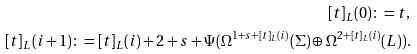Convert formula to latex. <formula><loc_0><loc_0><loc_500><loc_500>[ t ] _ { L } ( 0 ) \colon = t , \\ [ t ] _ { L } ( i + 1 ) \colon = [ t ] _ { L } ( i ) + 2 + s + \Psi ( \Omega ^ { 1 + s + [ t ] _ { L } ( i ) } ( \Sigma ) \oplus \Omega ^ { 2 + [ t ] _ { L } ( i ) } ( L ) ) .</formula> 